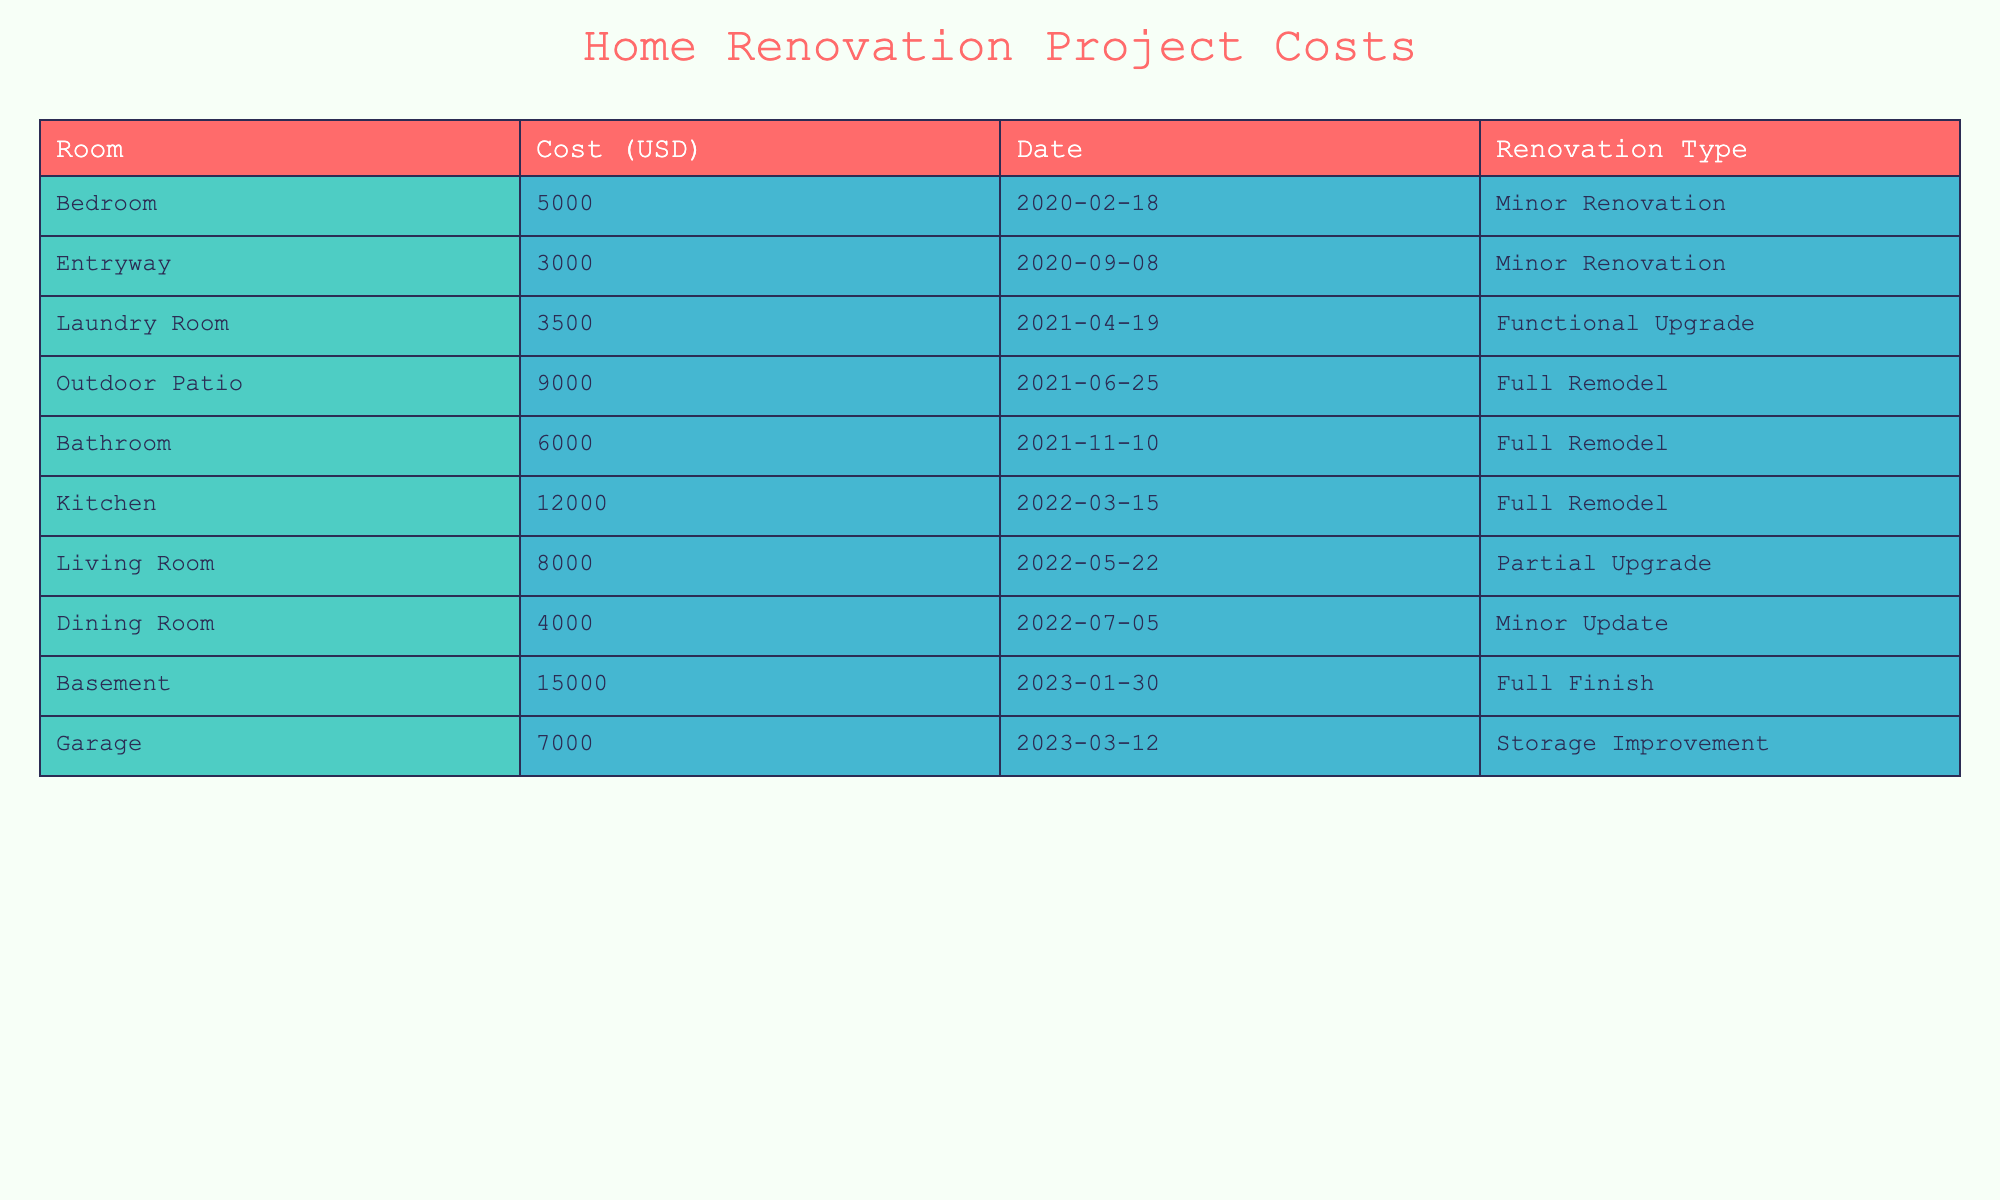What is the cost of the kitchen renovation? The table lists the renovation costs by room, and for the kitchen, the cost is specifically mentioned next to it. Therefore, the cost of the kitchen renovation is 12,000 USD.
Answer: 12,000 USD How much did the bathroom renovation cost compared to the living room? From the table, the bathroom renovation cost 6,000 USD, while the living room renovation cost 8,000 USD. To compare, simply note the difference: 8,000 USD (living room) - 6,000 USD (bathroom) = 2,000 USD.
Answer: 2,000 USD What is the average cost of a full remodel among the rooms listed? Review the table for full remodel projects: kitchen (12,000 USD), bathroom (6,000 USD), and outdoor patio (9,000 USD). The total cost for these remodels is 12,000 + 6,000 + 9,000 = 27,000 USD. There are 3 rooms, so average cost is 27,000 USD / 3 = 9,000 USD.
Answer: 9,000 USD Did the basement renovation happen before or after the garage improvement? The table shows that the basement was renovated on January 30, 2023, and the garage was improved on March 12, 2023. Since January comes before March, the basement renovation happened before the garage improvement.
Answer: Yes Which room had the highest renovation cost and what was that cost? By examining the costs listed in the table, the basement comes out with the highest renovation cost at 15,000 USD compared to all other rooms.
Answer: 15,000 USD What is the total sum of costs for minor renovations? Minor renovations in the table include the bedroom (5,000 USD) and entryway (3,000 USD) renovations. To calculate the total, sum them: 5,000 + 3,000 = 8,000 USD.
Answer: 8,000 USD Was there a renovation project for the dining room in 2022? The table indicates a dining room renovation on July 5, 2022, which confirms that a project did take place that year.
Answer: Yes How many renovations were recorded in total for the year 2022? Looking at the 2022 projects in the table: kitchen (March 15), living room (May 22), and dining room (July 5) gives us a total of 3 renovations for that year.
Answer: 3 